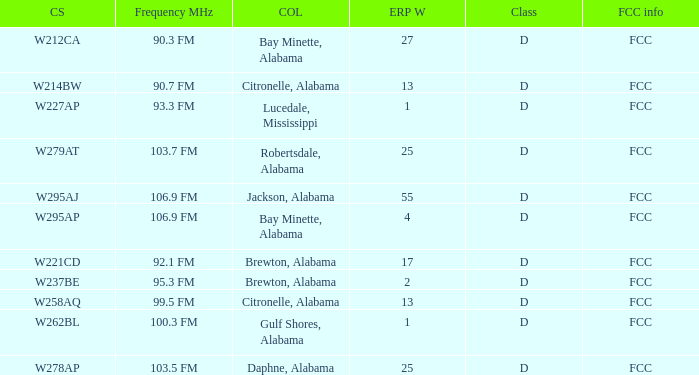Name the call sign for ERP W of 4 W295AP. 